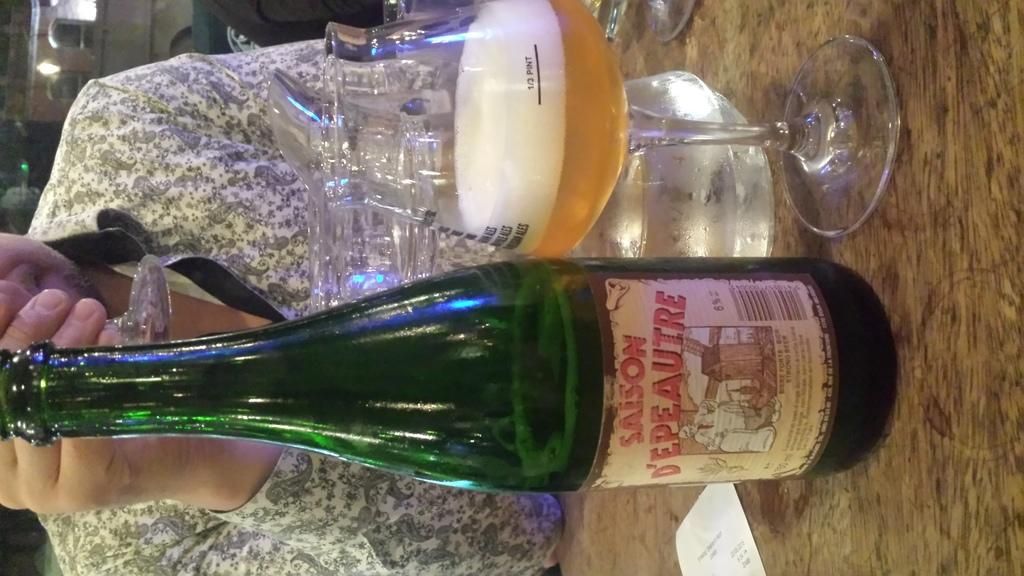<image>
Write a terse but informative summary of the picture. A bottle of Saison D'epeautre next to a quarter full glass. 